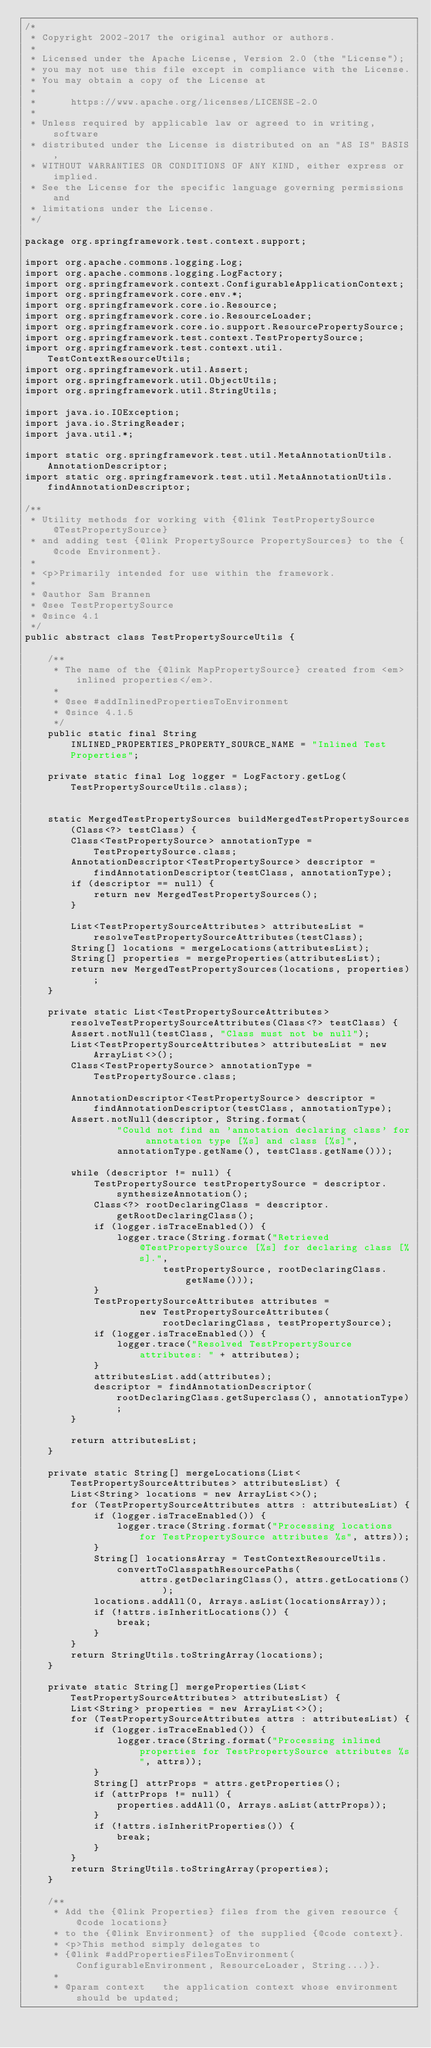<code> <loc_0><loc_0><loc_500><loc_500><_Java_>/*
 * Copyright 2002-2017 the original author or authors.
 *
 * Licensed under the Apache License, Version 2.0 (the "License");
 * you may not use this file except in compliance with the License.
 * You may obtain a copy of the License at
 *
 *      https://www.apache.org/licenses/LICENSE-2.0
 *
 * Unless required by applicable law or agreed to in writing, software
 * distributed under the License is distributed on an "AS IS" BASIS,
 * WITHOUT WARRANTIES OR CONDITIONS OF ANY KIND, either express or implied.
 * See the License for the specific language governing permissions and
 * limitations under the License.
 */

package org.springframework.test.context.support;

import org.apache.commons.logging.Log;
import org.apache.commons.logging.LogFactory;
import org.springframework.context.ConfigurableApplicationContext;
import org.springframework.core.env.*;
import org.springframework.core.io.Resource;
import org.springframework.core.io.ResourceLoader;
import org.springframework.core.io.support.ResourcePropertySource;
import org.springframework.test.context.TestPropertySource;
import org.springframework.test.context.util.TestContextResourceUtils;
import org.springframework.util.Assert;
import org.springframework.util.ObjectUtils;
import org.springframework.util.StringUtils;

import java.io.IOException;
import java.io.StringReader;
import java.util.*;

import static org.springframework.test.util.MetaAnnotationUtils.AnnotationDescriptor;
import static org.springframework.test.util.MetaAnnotationUtils.findAnnotationDescriptor;

/**
 * Utility methods for working with {@link TestPropertySource @TestPropertySource}
 * and adding test {@link PropertySource PropertySources} to the {@code Environment}.
 *
 * <p>Primarily intended for use within the framework.
 *
 * @author Sam Brannen
 * @see TestPropertySource
 * @since 4.1
 */
public abstract class TestPropertySourceUtils {

	/**
	 * The name of the {@link MapPropertySource} created from <em>inlined properties</em>.
	 *
	 * @see #addInlinedPropertiesToEnvironment
	 * @since 4.1.5
	 */
	public static final String INLINED_PROPERTIES_PROPERTY_SOURCE_NAME = "Inlined Test Properties";

	private static final Log logger = LogFactory.getLog(TestPropertySourceUtils.class);


	static MergedTestPropertySources buildMergedTestPropertySources(Class<?> testClass) {
		Class<TestPropertySource> annotationType = TestPropertySource.class;
		AnnotationDescriptor<TestPropertySource> descriptor = findAnnotationDescriptor(testClass, annotationType);
		if (descriptor == null) {
			return new MergedTestPropertySources();
		}

		List<TestPropertySourceAttributes> attributesList = resolveTestPropertySourceAttributes(testClass);
		String[] locations = mergeLocations(attributesList);
		String[] properties = mergeProperties(attributesList);
		return new MergedTestPropertySources(locations, properties);
	}

	private static List<TestPropertySourceAttributes> resolveTestPropertySourceAttributes(Class<?> testClass) {
		Assert.notNull(testClass, "Class must not be null");
		List<TestPropertySourceAttributes> attributesList = new ArrayList<>();
		Class<TestPropertySource> annotationType = TestPropertySource.class;

		AnnotationDescriptor<TestPropertySource> descriptor = findAnnotationDescriptor(testClass, annotationType);
		Assert.notNull(descriptor, String.format(
				"Could not find an 'annotation declaring class' for annotation type [%s] and class [%s]",
				annotationType.getName(), testClass.getName()));

		while (descriptor != null) {
			TestPropertySource testPropertySource = descriptor.synthesizeAnnotation();
			Class<?> rootDeclaringClass = descriptor.getRootDeclaringClass();
			if (logger.isTraceEnabled()) {
				logger.trace(String.format("Retrieved @TestPropertySource [%s] for declaring class [%s].",
						testPropertySource, rootDeclaringClass.getName()));
			}
			TestPropertySourceAttributes attributes =
					new TestPropertySourceAttributes(rootDeclaringClass, testPropertySource);
			if (logger.isTraceEnabled()) {
				logger.trace("Resolved TestPropertySource attributes: " + attributes);
			}
			attributesList.add(attributes);
			descriptor = findAnnotationDescriptor(rootDeclaringClass.getSuperclass(), annotationType);
		}

		return attributesList;
	}

	private static String[] mergeLocations(List<TestPropertySourceAttributes> attributesList) {
		List<String> locations = new ArrayList<>();
		for (TestPropertySourceAttributes attrs : attributesList) {
			if (logger.isTraceEnabled()) {
				logger.trace(String.format("Processing locations for TestPropertySource attributes %s", attrs));
			}
			String[] locationsArray = TestContextResourceUtils.convertToClasspathResourcePaths(
					attrs.getDeclaringClass(), attrs.getLocations());
			locations.addAll(0, Arrays.asList(locationsArray));
			if (!attrs.isInheritLocations()) {
				break;
			}
		}
		return StringUtils.toStringArray(locations);
	}

	private static String[] mergeProperties(List<TestPropertySourceAttributes> attributesList) {
		List<String> properties = new ArrayList<>();
		for (TestPropertySourceAttributes attrs : attributesList) {
			if (logger.isTraceEnabled()) {
				logger.trace(String.format("Processing inlined properties for TestPropertySource attributes %s", attrs));
			}
			String[] attrProps = attrs.getProperties();
			if (attrProps != null) {
				properties.addAll(0, Arrays.asList(attrProps));
			}
			if (!attrs.isInheritProperties()) {
				break;
			}
		}
		return StringUtils.toStringArray(properties);
	}

	/**
	 * Add the {@link Properties} files from the given resource {@code locations}
	 * to the {@link Environment} of the supplied {@code context}.
	 * <p>This method simply delegates to
	 * {@link #addPropertiesFilesToEnvironment(ConfigurableEnvironment, ResourceLoader, String...)}.
	 *
	 * @param context   the application context whose environment should be updated;</code> 